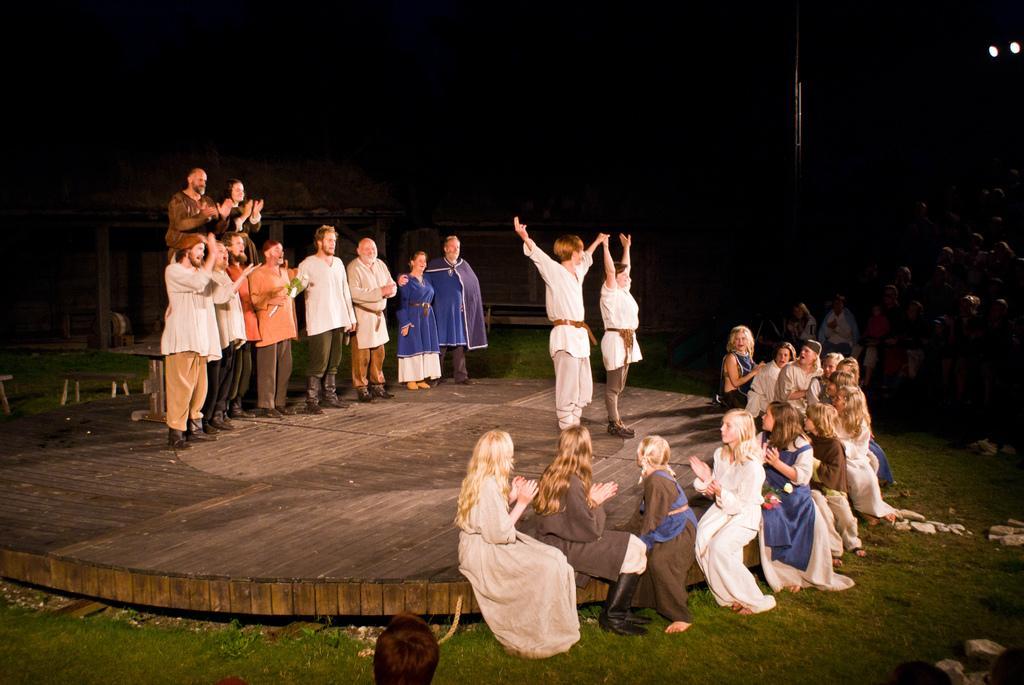Can you describe this image briefly? This image consists of many persons. It looks like they are acting in a play. They are standing on the dais. The dais is made up of wood. At the bottom, there is green grass on the ground. The background is too dark. On the right, we can see a huge crowd. 